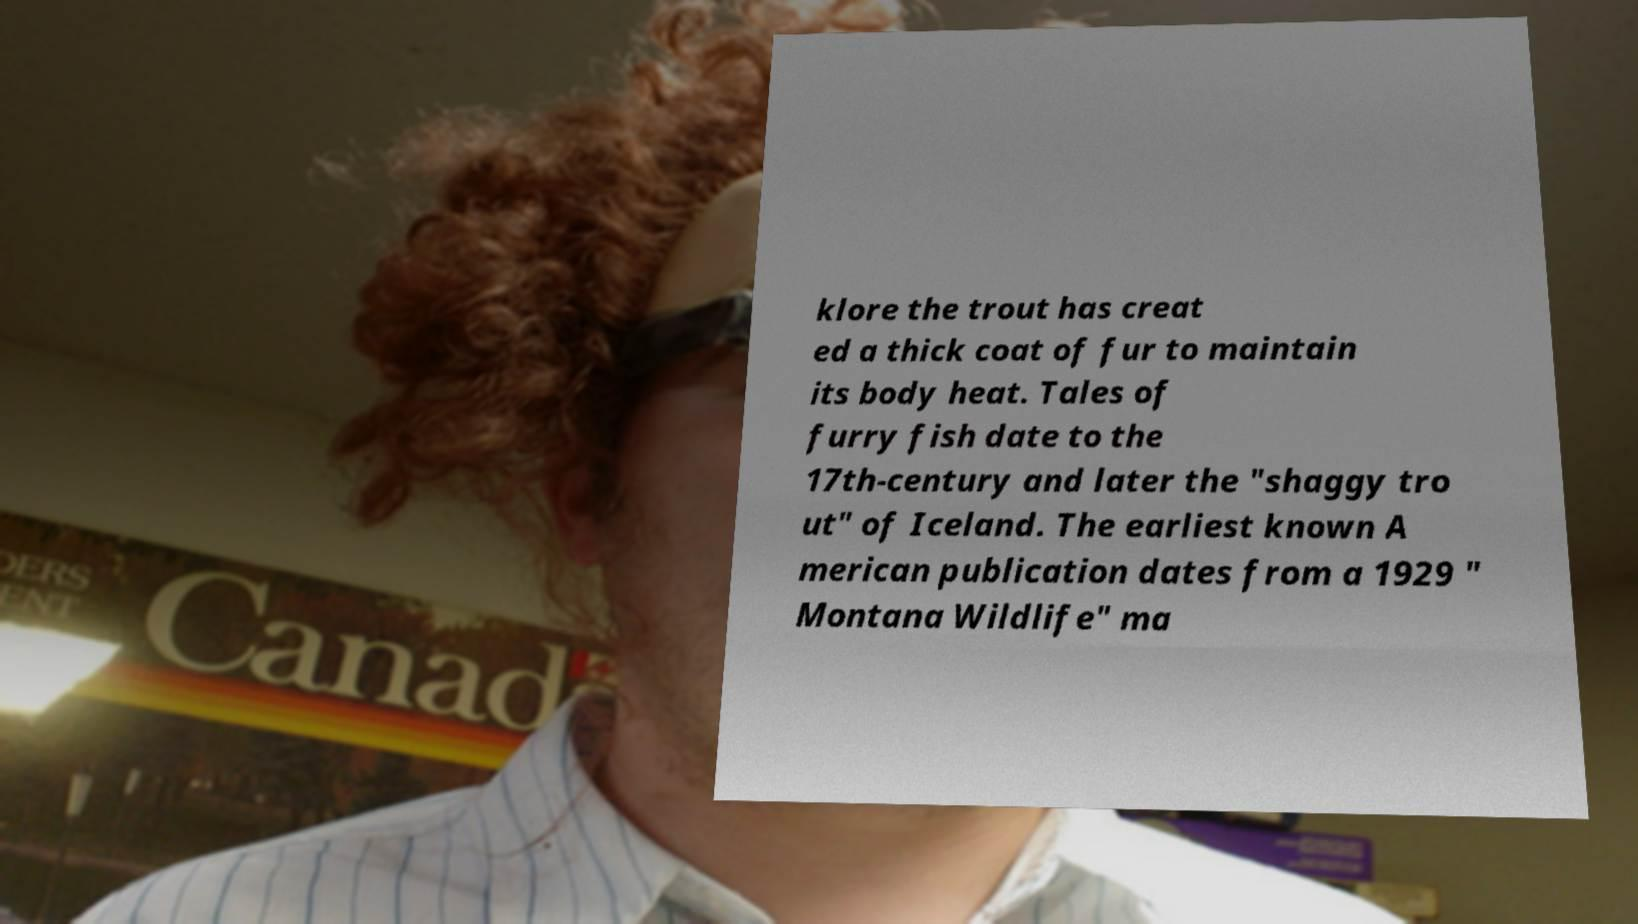Could you extract and type out the text from this image? klore the trout has creat ed a thick coat of fur to maintain its body heat. Tales of furry fish date to the 17th-century and later the "shaggy tro ut" of Iceland. The earliest known A merican publication dates from a 1929 " Montana Wildlife" ma 